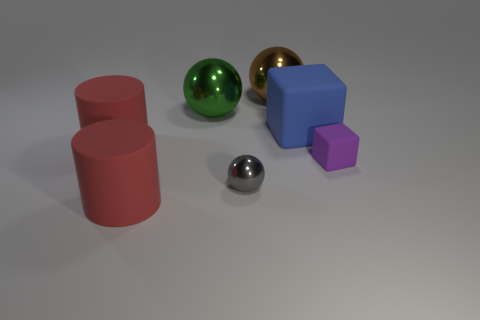Add 1 large brown metal things. How many objects exist? 8 Subtract all cylinders. How many objects are left? 5 Add 5 small balls. How many small balls are left? 6 Add 2 gray matte things. How many gray matte things exist? 2 Subtract 1 purple cubes. How many objects are left? 6 Subtract all blocks. Subtract all gray shiny spheres. How many objects are left? 4 